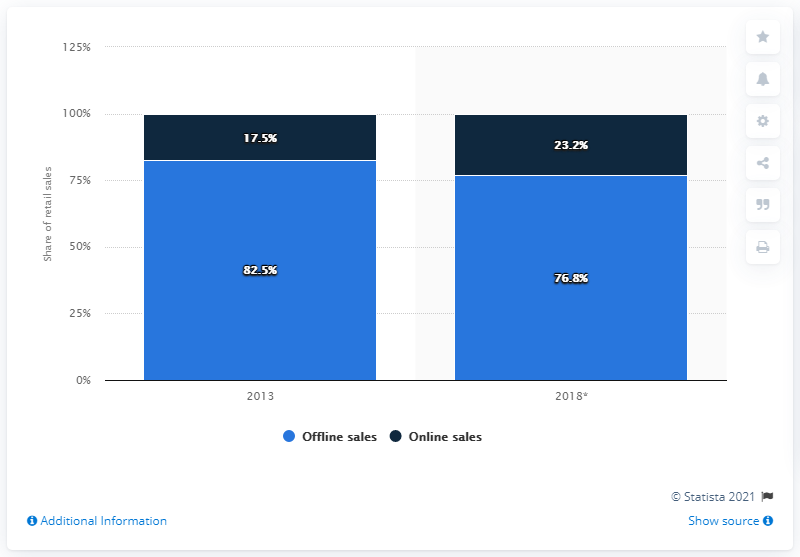In what year did online sales make up 17.5% of electricals and electronics sales in Germany? According to the provided image, online sales constituted 17.5% of the electricals and electronics sales market in Germany in the year 2013, contrasting with 82.5% for offline sales during the same period. 